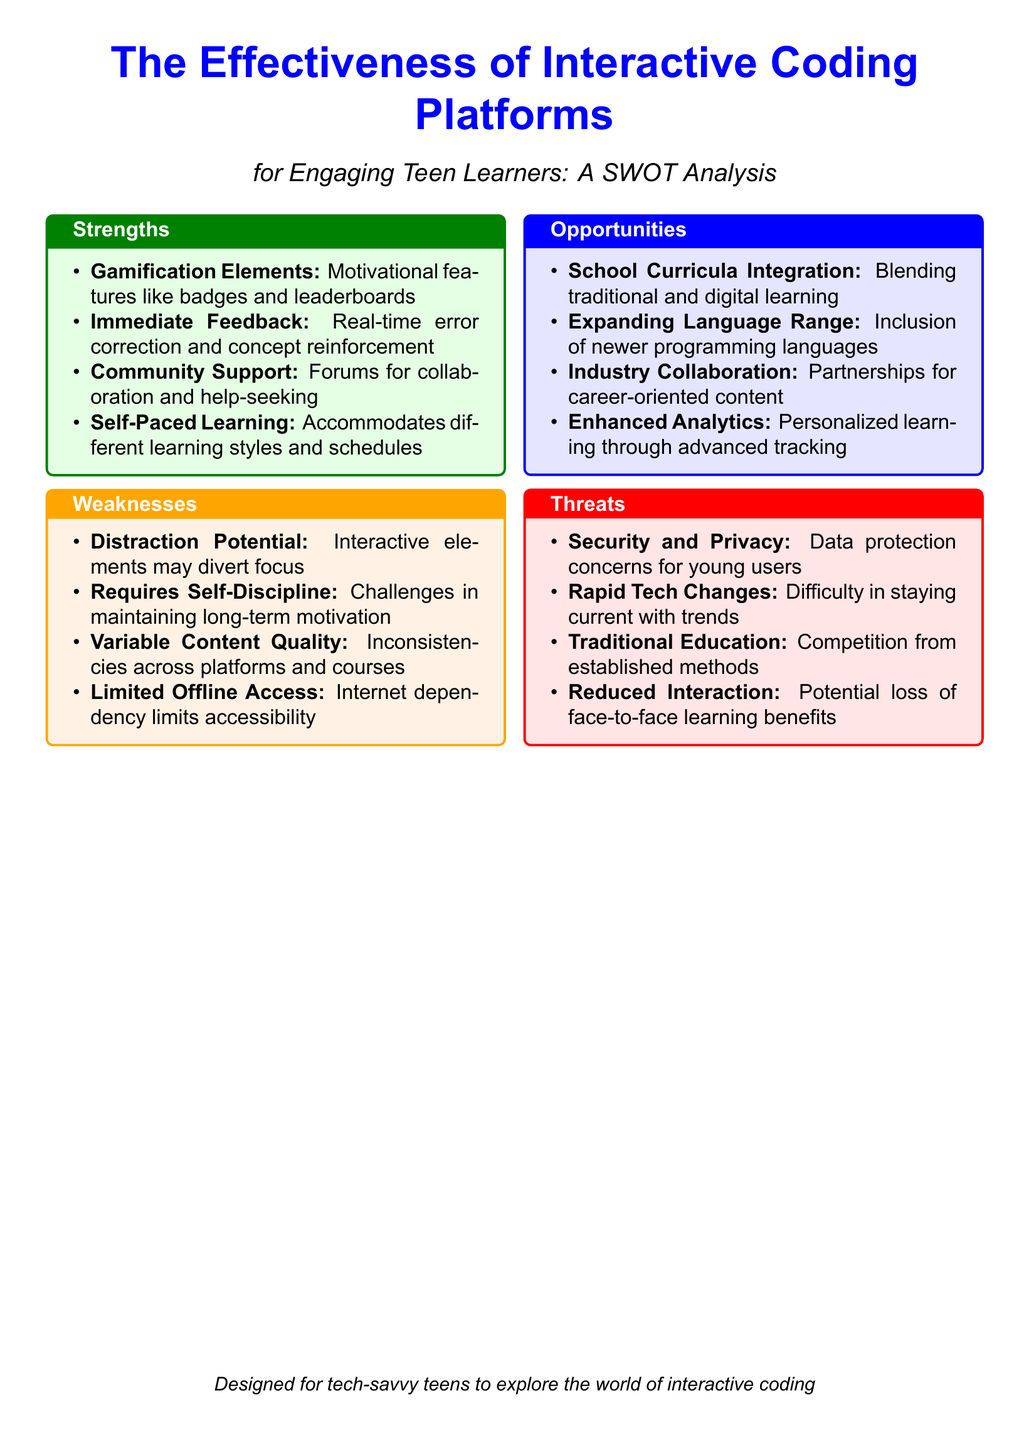What are gamification elements? The document mentions that motivational features include badges and leaderboards as part of the strengths of interactive coding platforms.
Answer: Badges and leaderboards What is a weakness related to self-discipline? The document states that maintaining long-term motivation can be a challenge, highlighting a weakness in interactive coding platforms.
Answer: Requires self-discipline What opportunity involves school? The document suggests that blending traditional and digital learning creates an opportunity for interactive coding platforms.
Answer: School curricula integration What is a threat about data? The document identifies data protection concerns for young users as a threat to interactive coding platforms.
Answer: Security and privacy How many strengths are listed? The document outlines a total of four strengths in the SWOT analysis of interactive coding platforms.
Answer: Four 